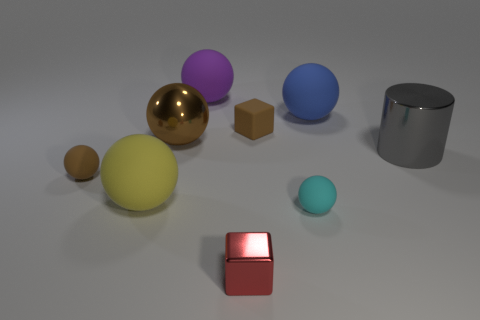There is a big ball that is to the right of the small matte thing behind the cylinder; are there any big balls to the left of it?
Provide a short and direct response. Yes. Are there any red matte blocks?
Offer a terse response. No. Are there more large matte spheres that are left of the purple matte sphere than gray objects behind the big brown metallic ball?
Provide a succinct answer. Yes. What is the size of the cyan ball that is made of the same material as the purple object?
Offer a terse response. Small. There is a metallic thing that is to the right of the small brown matte block behind the ball that is left of the yellow rubber object; how big is it?
Offer a very short reply. Large. What color is the small matte object that is behind the large metal cylinder?
Provide a short and direct response. Brown. Are there more big brown shiny things behind the brown matte cube than cyan spheres?
Your answer should be compact. No. There is a big metallic thing that is left of the big purple matte ball; does it have the same shape as the tiny cyan rubber object?
Ensure brevity in your answer.  Yes. What number of green objects are either rubber objects or shiny cylinders?
Your response must be concise. 0. Are there more small shiny spheres than tiny metallic things?
Your response must be concise. No. 